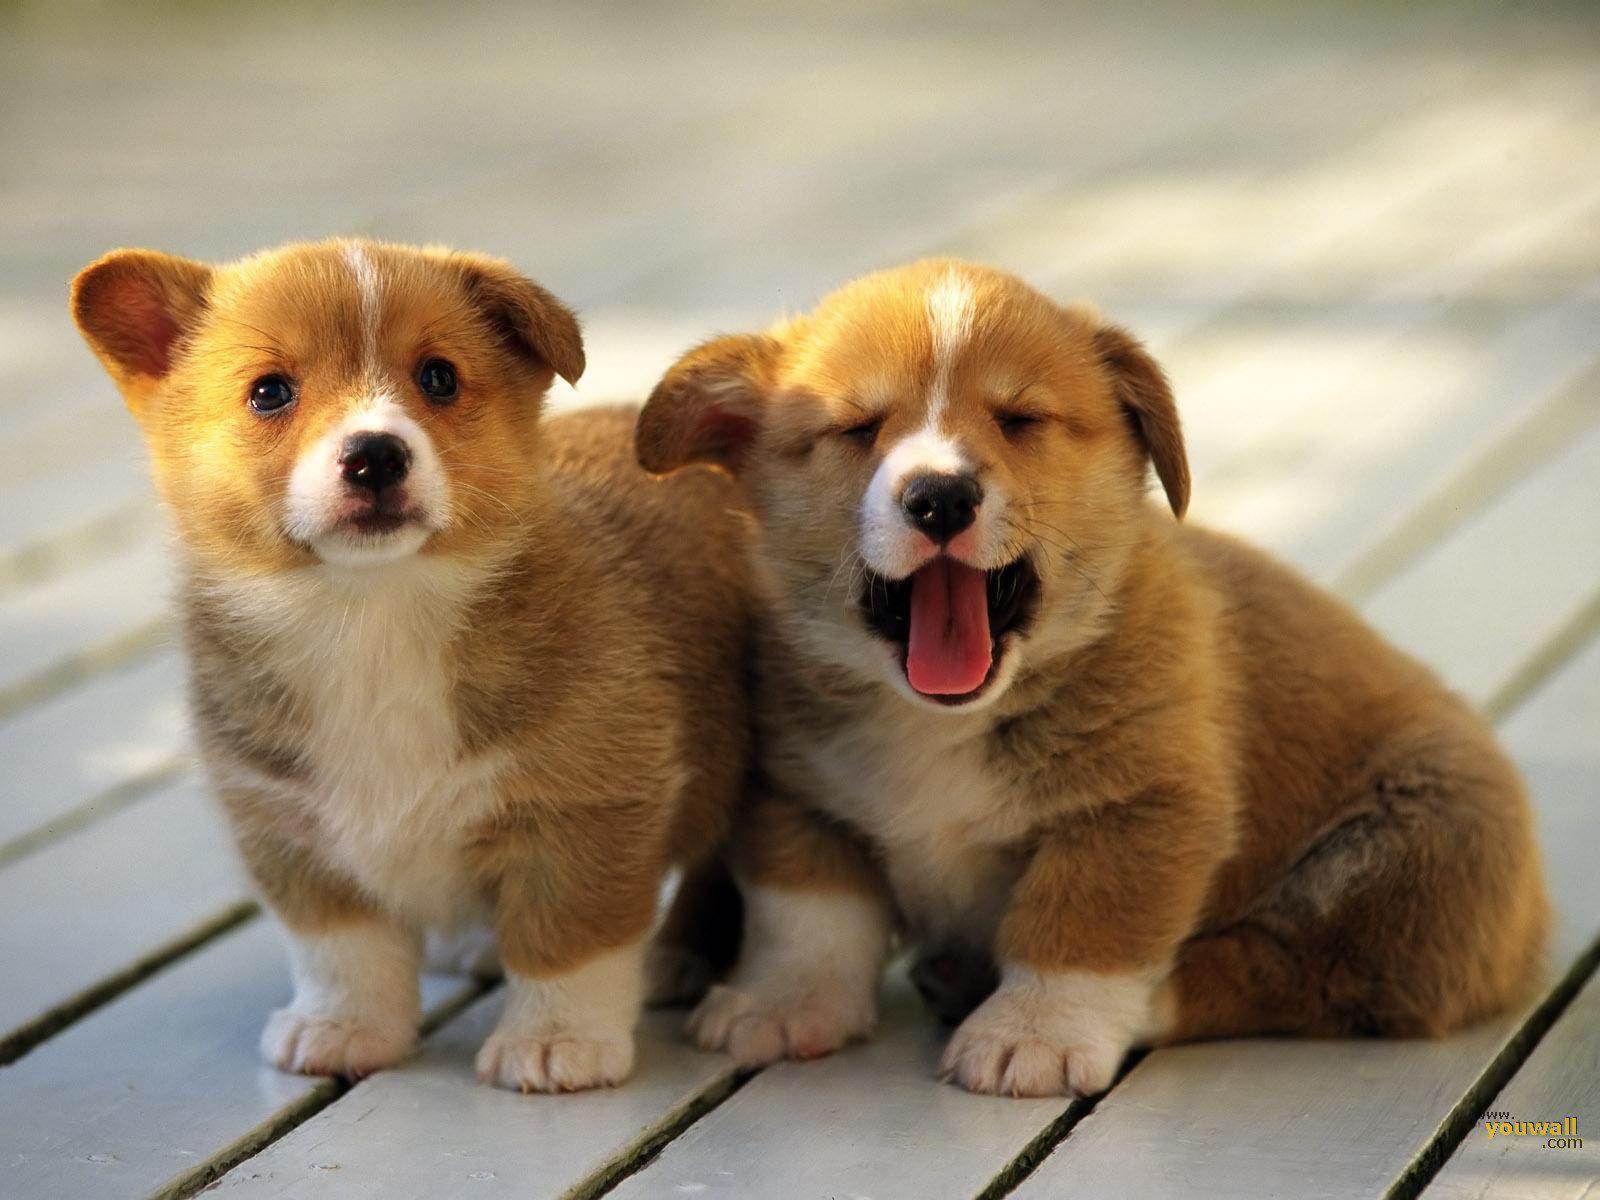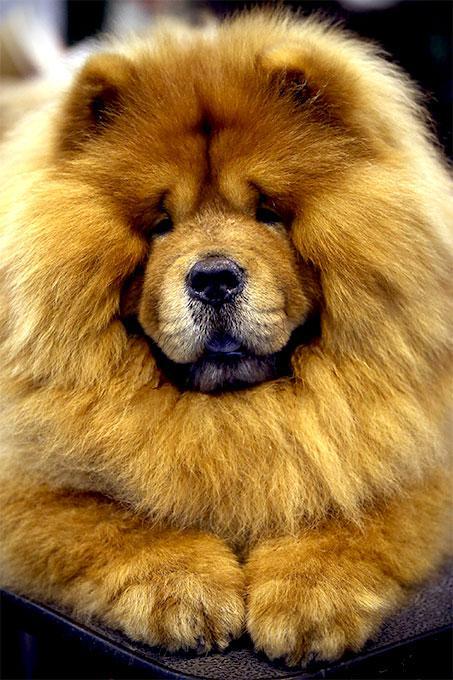The first image is the image on the left, the second image is the image on the right. Examine the images to the left and right. Is the description "The dogs on the left are facing right." accurate? Answer yes or no. No. 